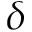Convert formula to latex. <formula><loc_0><loc_0><loc_500><loc_500>\delta</formula> 